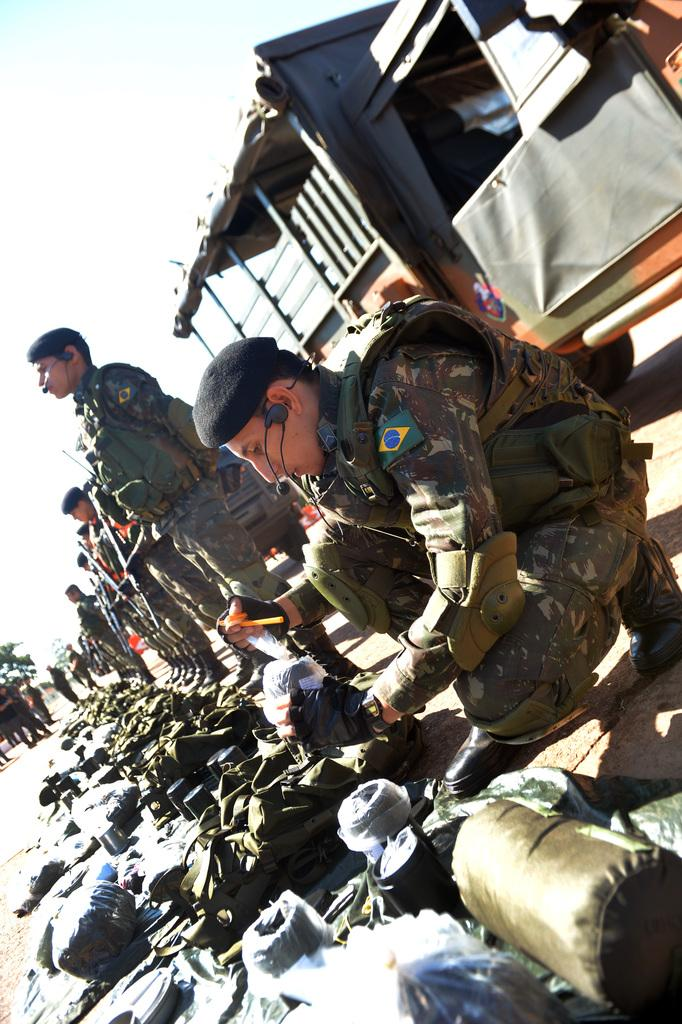What is happening on the road in the image? There are people on the road in the image. Can you describe the appearance of some of the people? Some of the people are wearing uniforms. What are some of the people holding in the image? Some of the people are holding guns. What can be seen on the ground in the image? There are objects on the ground in the image. What type of vehicle is present in the image? There is a vehicle in the image. What type of natural elements can be seen in the image? There are trees in the image. What type of rings can be seen on the trees in the image? There are no rings visible on the trees in the image. 